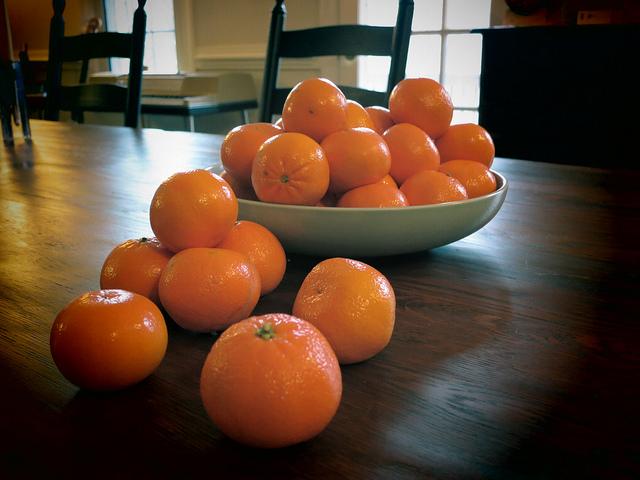Are these fruits or vegetables?
Concise answer only. Fruits. What color are the objects in the picture?
Answer briefly. Orange. How many chairs do you see?
Write a very short answer. 2. What is the color of bowl were fruits are?
Keep it brief. White. 